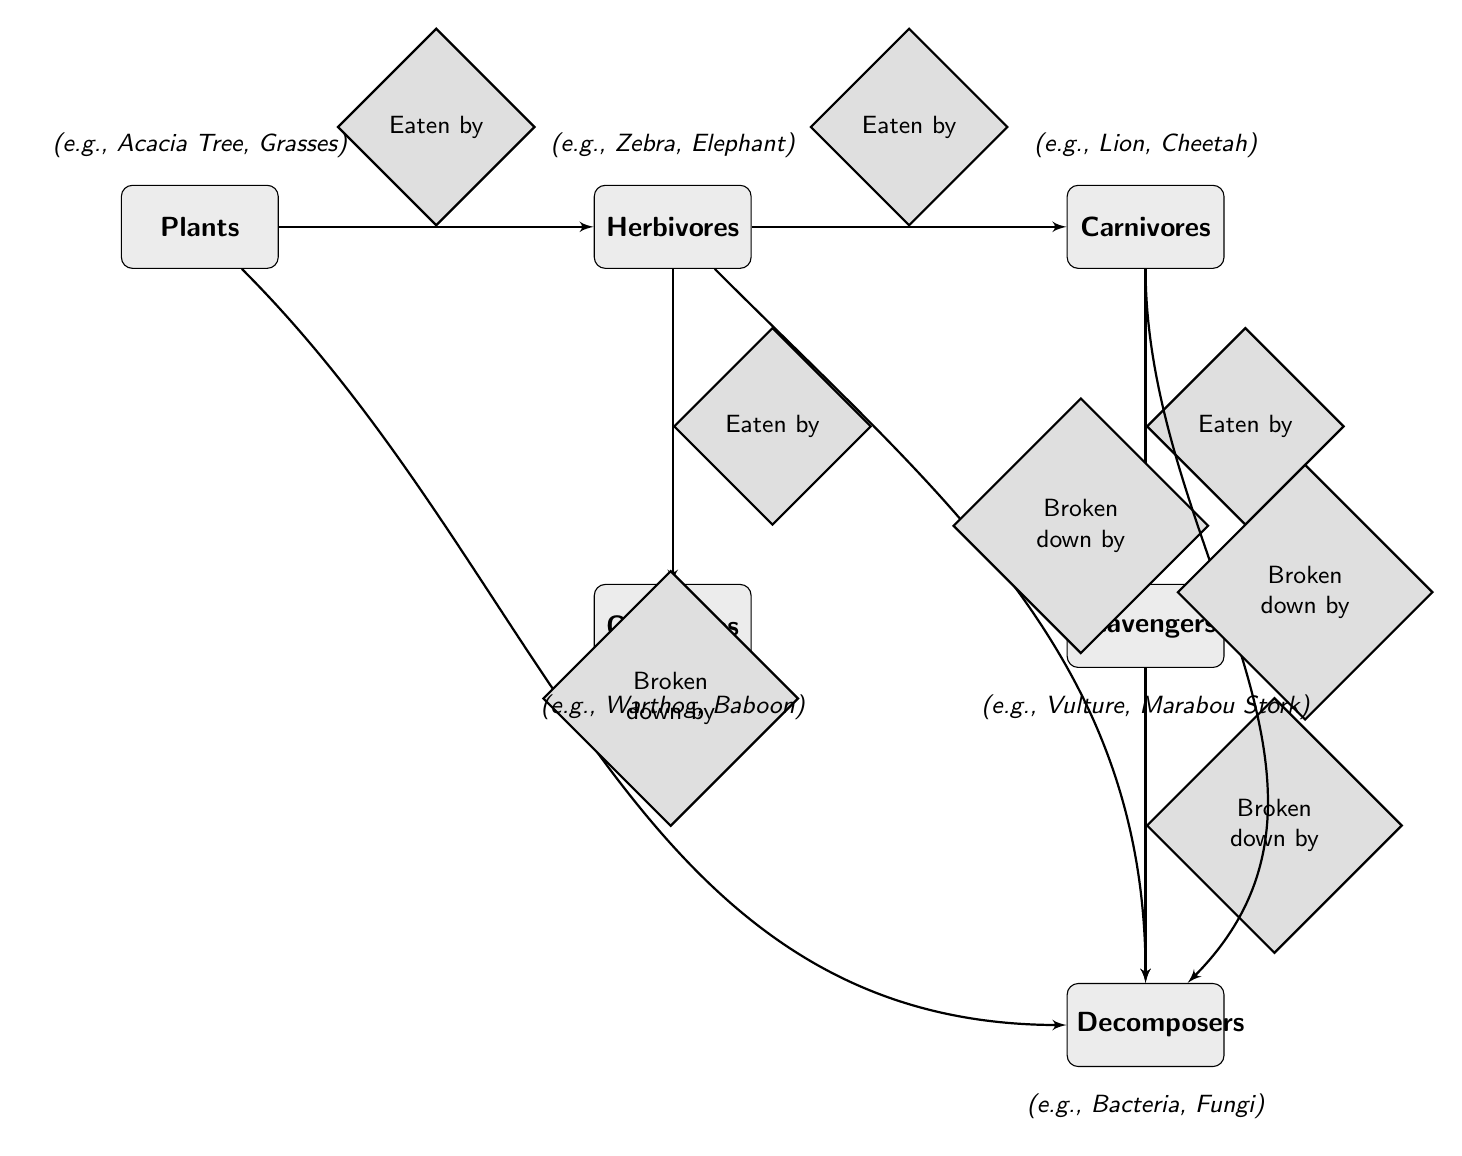What type of entity is "Zebra"? In the diagram, the "Zebra" is listed under "Herbivores" which are classified as primary consumers.
Answer: primary consumer How many types of consumers are shown in the diagram? The diagram displays two types of consumers: primary consumers (herbivores) and secondary consumers (carnivores and omnivores). Counting these gives a total of three distinct types.
Answer: 3 What is the relationship between "Herbivores" and "Carnivores"? The diagram indicates a direct relationship where herbivores are eaten by carnivores, defined by the arrow labeled "Eaten by".
Answer: Eaten by Which entity is at the bottom of the food web? The diagram shows "Decomposers" at the bottom. This entity is the last in the vertical arrangement of entities.
Answer: Decomposers How many examples are provided for "Carnivores"? The diagram provides three examples for "Carnivores": Lion, Cheetah, and Hyena, indicating distinct species within that category.
Answer: 3 Which group directly breaks down "Scavengers"? The "Scavengers" are broken down by "Decomposers," as shown in the relationship labeled "Broken down by" pointing from scavengers to decomposers.
Answer: Decomposers If an herbivore is consumed, what type of entity does it classify into? When an herbivore is consumed, as shown in the diagram, it is classified as a prey and contributes to secondary consumers, such as carnivores and omnivores, based on the relationships outlined.
Answer: secondary consumers What examples are under "Plants"? The diagram lists Acacia Tree and Grasses as examples under the "Plants" category, indicating common producers in the ecosystem.
Answer: Acacia Tree, Grasses How many distinct entities are represented in the diagram? The diagram shows six distinct entities: Plants, Herbivores, Carnivores, Omnivores, Scavengers, and Decomposers, totaling them gives the answer.
Answer: 6 